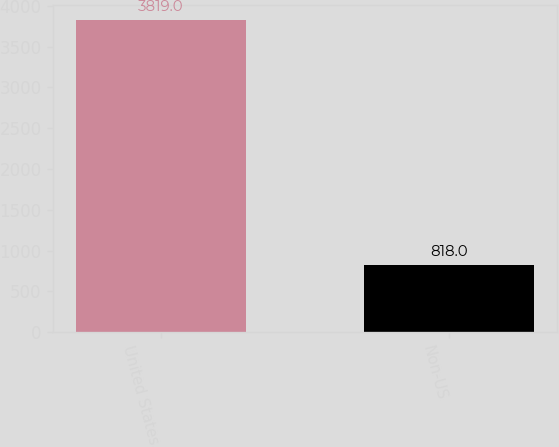Convert chart to OTSL. <chart><loc_0><loc_0><loc_500><loc_500><bar_chart><fcel>United States<fcel>Non-US<nl><fcel>3819<fcel>818<nl></chart> 